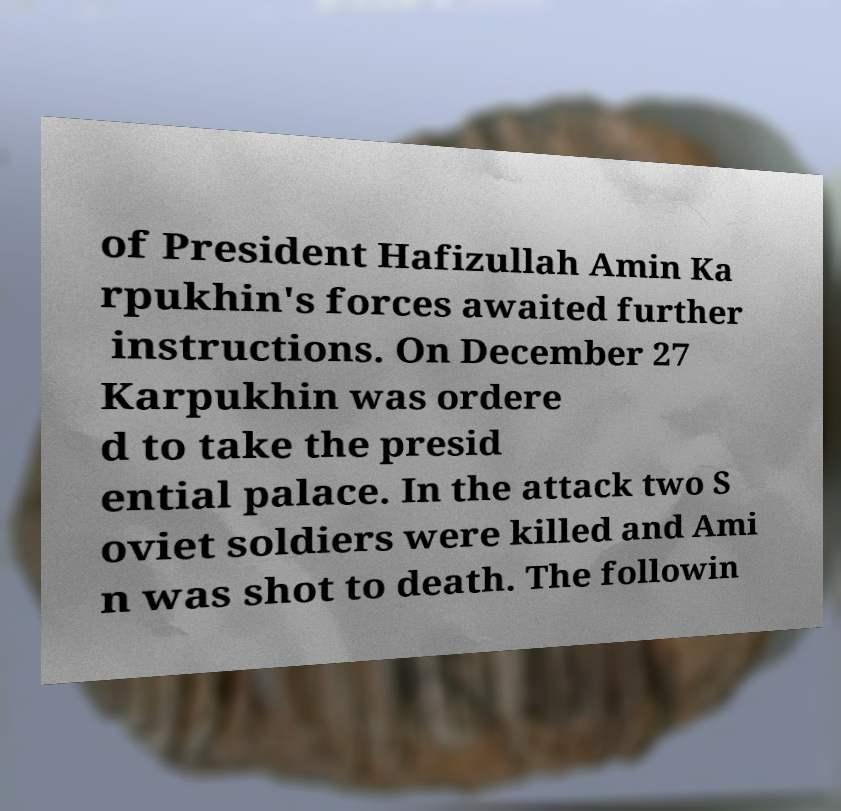Can you read and provide the text displayed in the image?This photo seems to have some interesting text. Can you extract and type it out for me? of President Hafizullah Amin Ka rpukhin's forces awaited further instructions. On December 27 Karpukhin was ordere d to take the presid ential palace. In the attack two S oviet soldiers were killed and Ami n was shot to death. The followin 